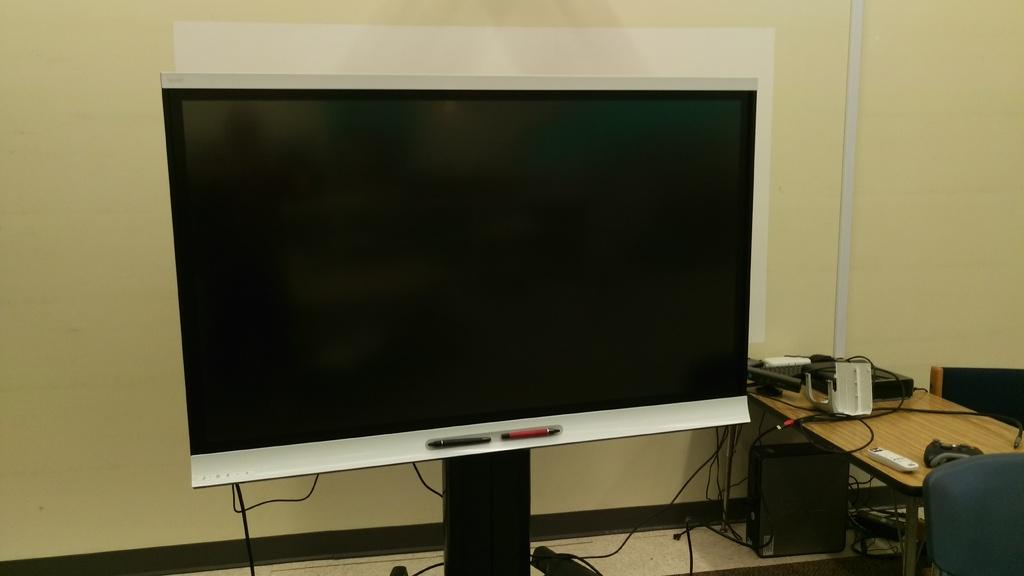What is the main object in the image? There is a screen in the image. What piece of furniture is present in the image? There is a table and chairs in the image. What items can be seen on the table? There are boxes on the table. Where is the CPU located in the image? The CPU is under the table. How many ducks are sitting on the roof in the image? There are no ducks or roof present in the image. 